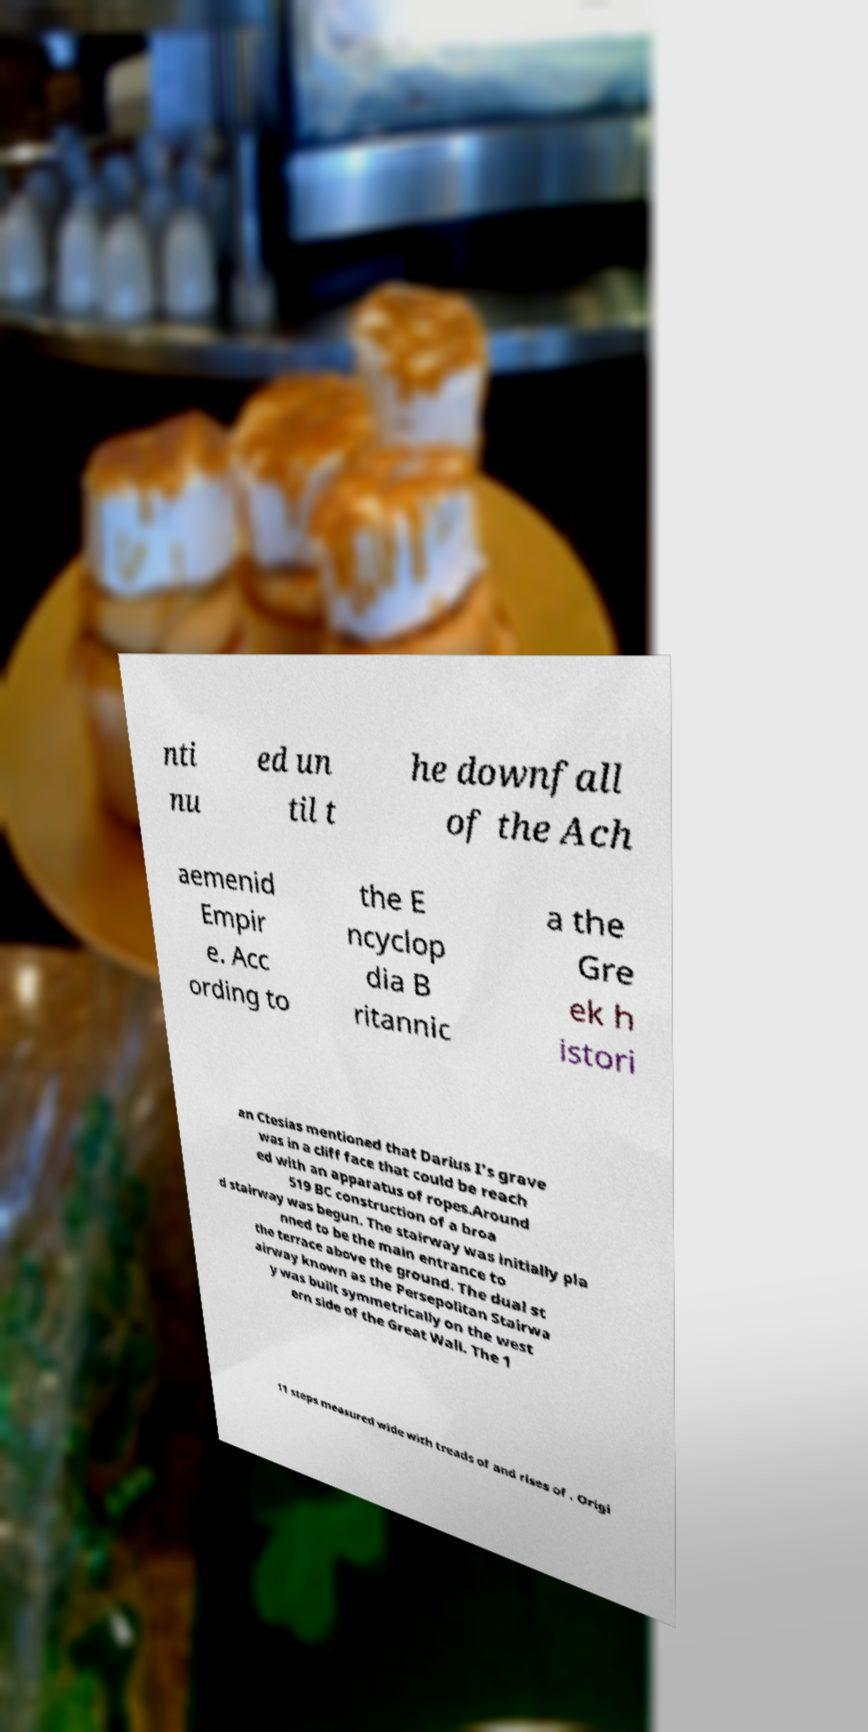Please read and relay the text visible in this image. What does it say? nti nu ed un til t he downfall of the Ach aemenid Empir e. Acc ording to the E ncyclop dia B ritannic a the Gre ek h istori an Ctesias mentioned that Darius I's grave was in a cliff face that could be reach ed with an apparatus of ropes.Around 519 BC construction of a broa d stairway was begun. The stairway was initially pla nned to be the main entrance to the terrace above the ground. The dual st airway known as the Persepolitan Stairwa y was built symmetrically on the west ern side of the Great Wall. The 1 11 steps measured wide with treads of and rises of . Origi 